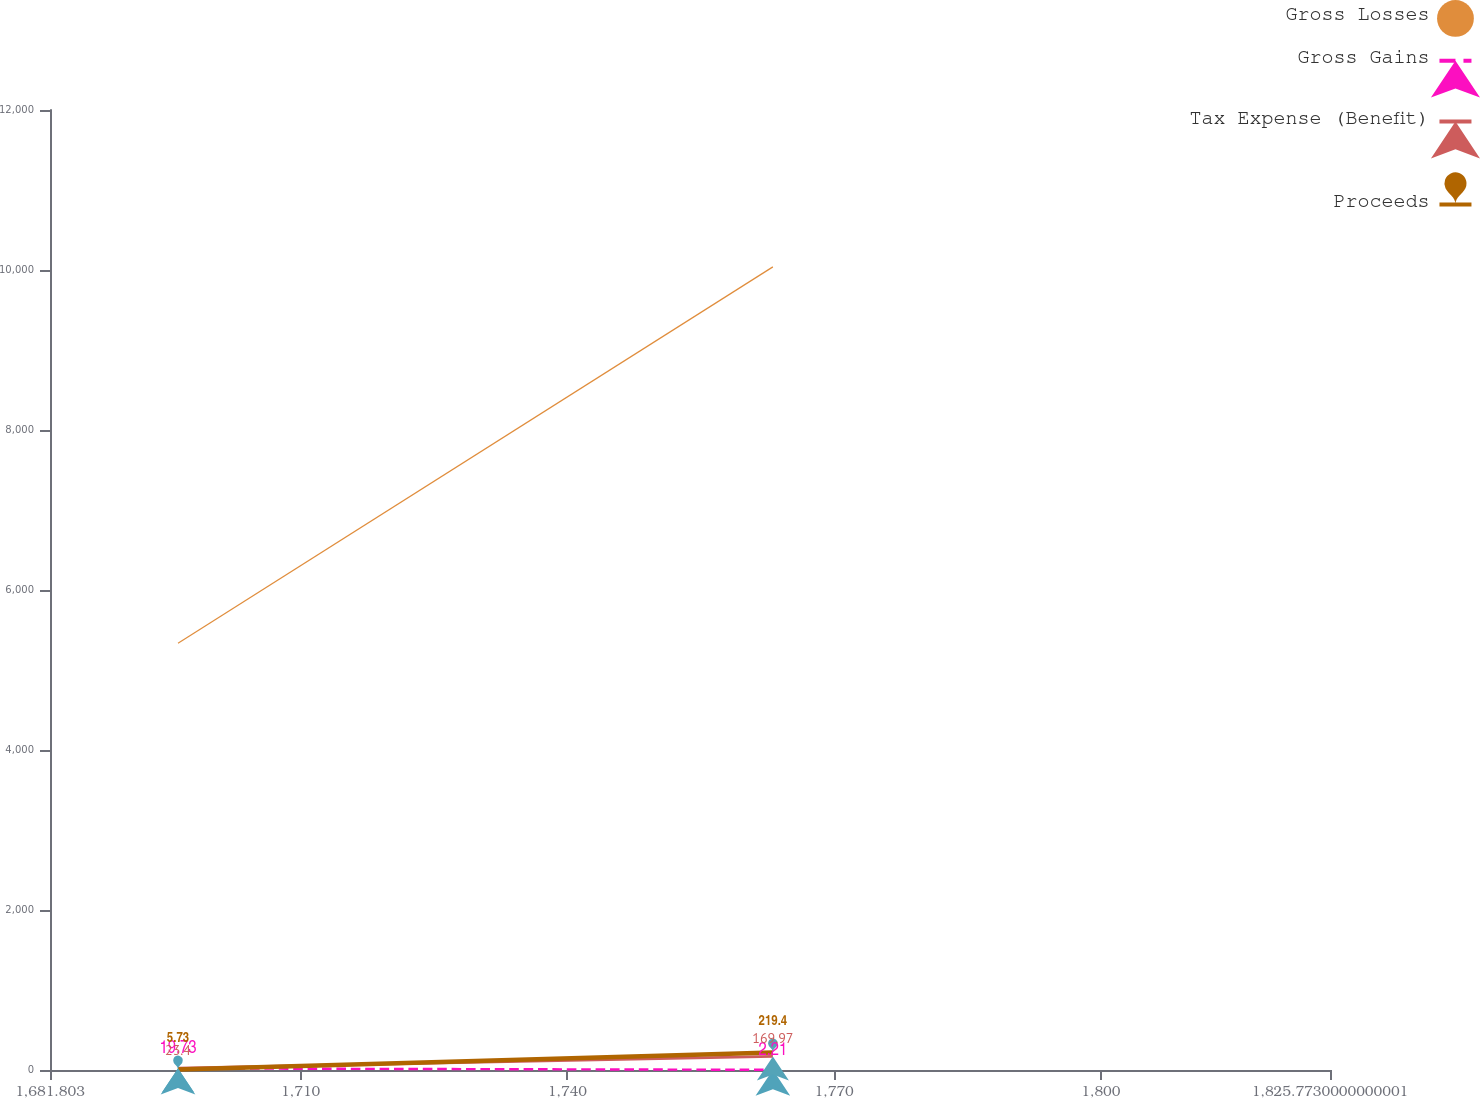<chart> <loc_0><loc_0><loc_500><loc_500><line_chart><ecel><fcel>Gross Losses<fcel>Gross Gains<fcel>Tax Expense (Benefit)<fcel>Proceeds<nl><fcel>1696.2<fcel>5333.74<fcel>19.73<fcel>23.4<fcel>5.73<nl><fcel>1763.11<fcel>10039.1<fcel>2.21<fcel>169.97<fcel>219.4<nl><fcel>1840.17<fcel>12615.2<fcel>15.93<fcel>57.18<fcel>38.89<nl></chart> 